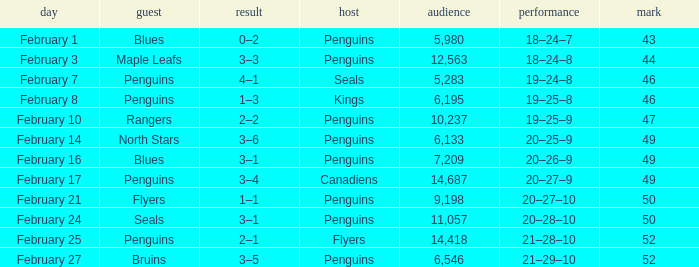Home of kings had what score? 1–3. 